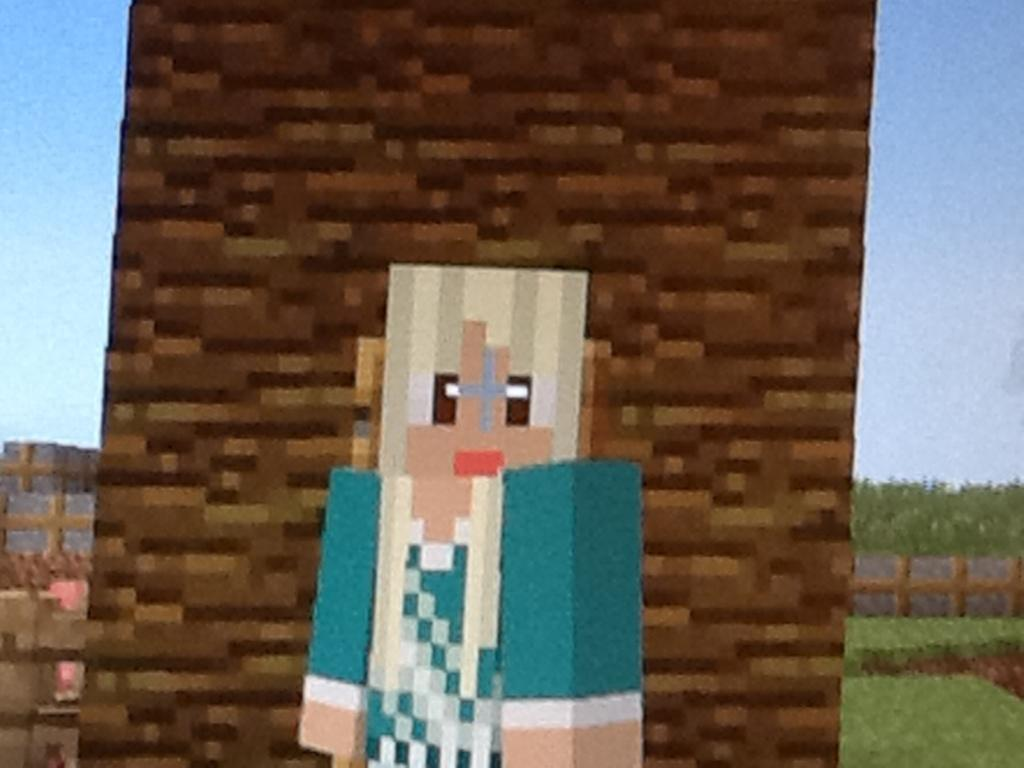What type of image is being described? The image is graphical in nature. What is the main subject of the image? There is a picture in the image. What structures are present in the image? There is a wall and a fence in the image. What type of vegetation is visible in the image? There is grass and trees in the image. What else can be seen in the image? There are objects in the image. What is visible in the background of the image? The sky is visible in the background of the image. What role does the minister play in the history of the image? There is no minister or historical context mentioned in the image, so it is not possible to answer that question. 